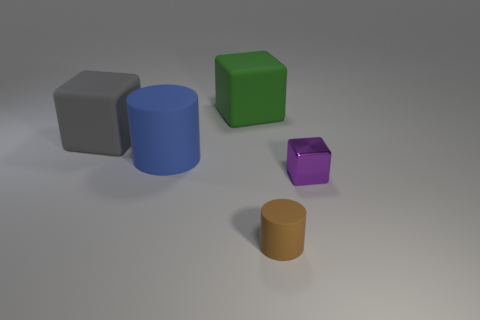There is a green thing on the right side of the blue cylinder; does it have the same shape as the shiny object?
Your answer should be compact. Yes. What size is the matte cylinder that is left of the matte cylinder that is on the right side of the blue rubber cylinder?
Give a very brief answer. Large. What is the color of the small thing that is the same material as the green block?
Offer a terse response. Brown. How many blue matte things have the same size as the purple metallic block?
Your response must be concise. 0. What number of gray objects are metallic cubes or matte blocks?
Keep it short and to the point. 1. What number of things are big gray objects or rubber blocks on the left side of the large blue object?
Give a very brief answer. 1. What is the material of the tiny object that is to the right of the tiny brown cylinder?
Keep it short and to the point. Metal. There is a green object that is the same size as the blue object; what is its shape?
Offer a terse response. Cube. Is there another large rubber object of the same shape as the big green thing?
Your answer should be compact. Yes. Is the brown cylinder made of the same material as the cube that is to the right of the small brown rubber object?
Offer a terse response. No. 